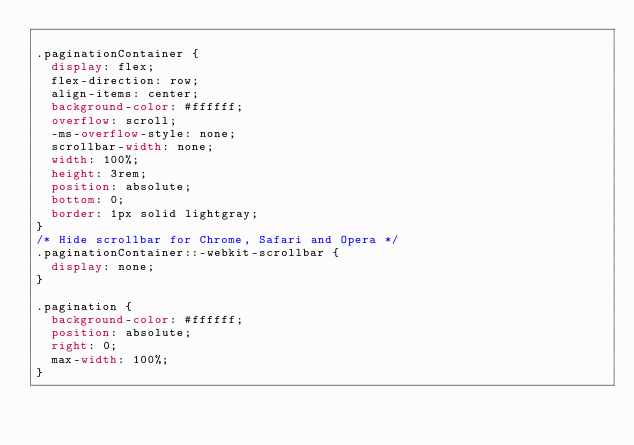Convert code to text. <code><loc_0><loc_0><loc_500><loc_500><_CSS_>
.paginationContainer {
  display: flex;
  flex-direction: row;
  align-items: center;
  background-color: #ffffff;
  overflow: scroll;
  -ms-overflow-style: none;
  scrollbar-width: none;
  width: 100%;
  height: 3rem;
  position: absolute;
  bottom: 0;
  border: 1px solid lightgray;
}
/* Hide scrollbar for Chrome, Safari and Opera */
.paginationContainer::-webkit-scrollbar {
  display: none;
}

.pagination {
  background-color: #ffffff;
  position: absolute;
  right: 0;
  max-width: 100%;
}
</code> 